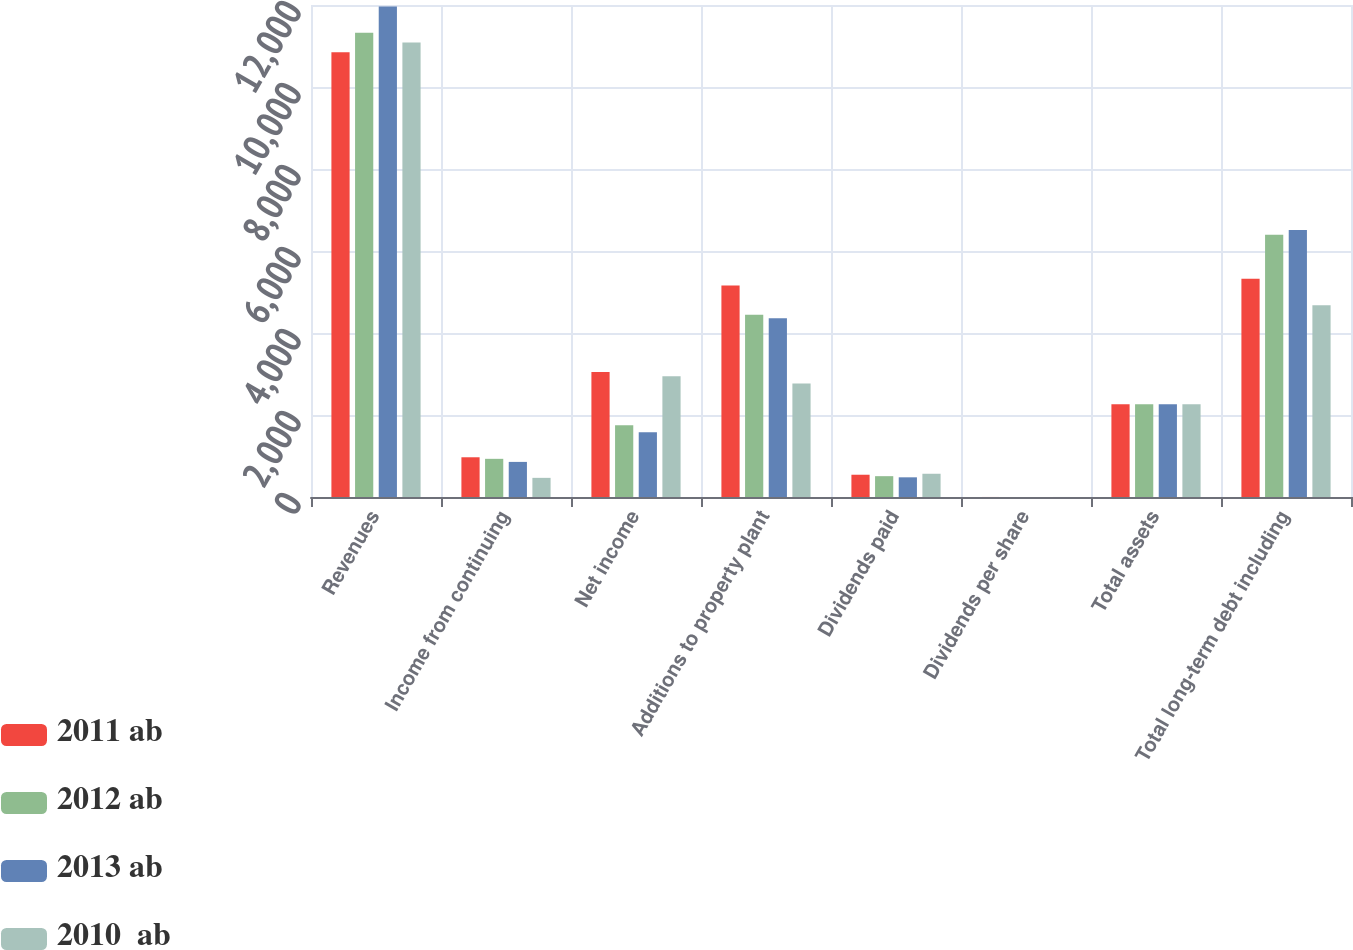<chart> <loc_0><loc_0><loc_500><loc_500><stacked_bar_chart><ecel><fcel>Revenues<fcel>Income from continuing<fcel>Net income<fcel>Additions to property plant<fcel>Dividends paid<fcel>Dividends per share<fcel>Total assets<fcel>Total long-term debt including<nl><fcel>2011 ab<fcel>10846<fcel>969<fcel>3046<fcel>5160<fcel>543<fcel>0.8<fcel>2260<fcel>5323<nl><fcel>2012 ab<fcel>11325<fcel>931<fcel>1753<fcel>4443<fcel>508<fcel>0.72<fcel>2260<fcel>6394<nl><fcel>2013 ab<fcel>11966<fcel>856<fcel>1582<fcel>4361<fcel>480<fcel>0.68<fcel>2260<fcel>6512<nl><fcel>2010  ab<fcel>11088<fcel>467<fcel>2946<fcel>2767<fcel>567<fcel>0.8<fcel>2260<fcel>4674<nl></chart> 